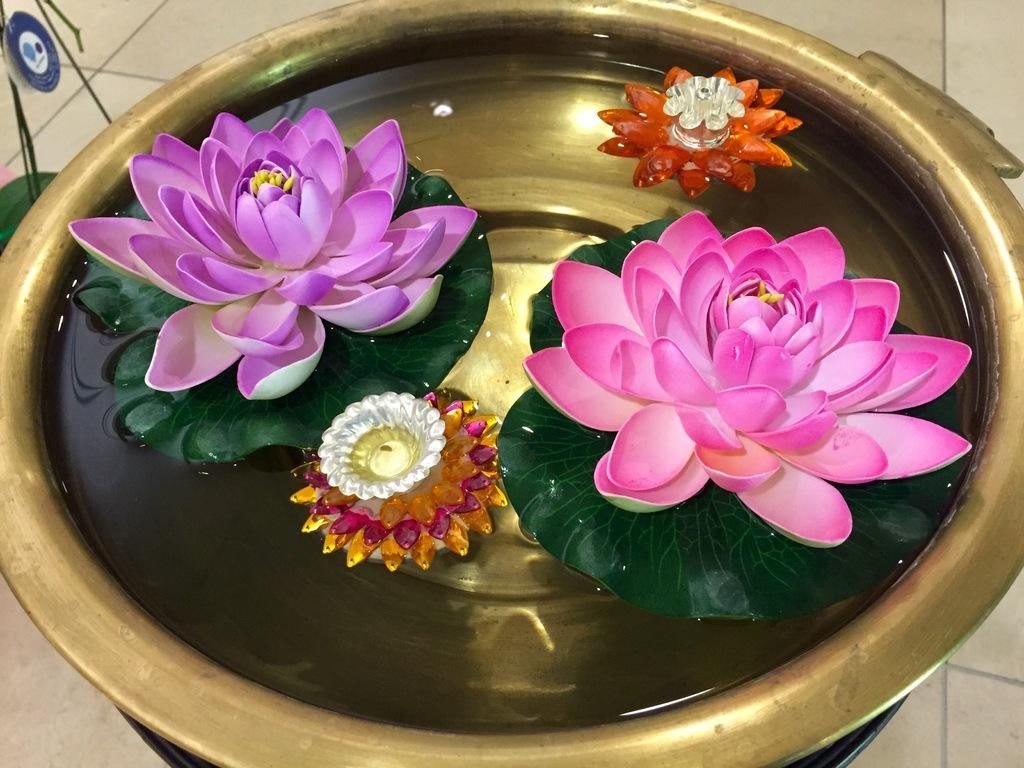What type of bowl is in the image? There is a metal bowl in the image. What is inside the metal bowl? There is water in the metal bowl. What decorative items are in the water? There are plastic flowers and diyas in the water. What type of ice can be seen melting in the metal bowl? There is no ice present in the image; it contains water, plastic flowers, and diyas. What kind of beast is lurking near the metal bowl? There is no beast present in the image; it only features a metal bowl with water, plastic flowers, and diyas. 